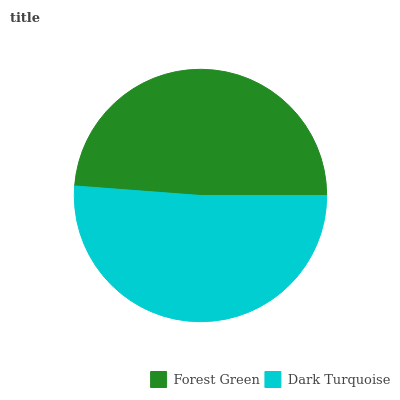Is Forest Green the minimum?
Answer yes or no. Yes. Is Dark Turquoise the maximum?
Answer yes or no. Yes. Is Dark Turquoise the minimum?
Answer yes or no. No. Is Dark Turquoise greater than Forest Green?
Answer yes or no. Yes. Is Forest Green less than Dark Turquoise?
Answer yes or no. Yes. Is Forest Green greater than Dark Turquoise?
Answer yes or no. No. Is Dark Turquoise less than Forest Green?
Answer yes or no. No. Is Dark Turquoise the high median?
Answer yes or no. Yes. Is Forest Green the low median?
Answer yes or no. Yes. Is Forest Green the high median?
Answer yes or no. No. Is Dark Turquoise the low median?
Answer yes or no. No. 